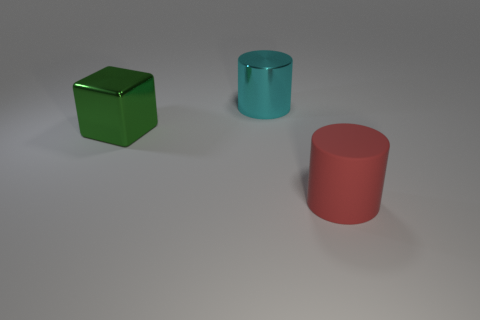What is the shape of the green object that is the same size as the red object?
Your answer should be compact. Cube. What shape is the matte object that is in front of the large cylinder behind the big cylinder that is in front of the cyan thing?
Offer a very short reply. Cylinder. Are there an equal number of cyan shiny cylinders in front of the green shiny cube and big blue rubber balls?
Your answer should be very brief. Yes. What number of matte objects are small cubes or green objects?
Your answer should be compact. 0. There is a red cylinder that is the same size as the green metal thing; what material is it?
Provide a short and direct response. Rubber. What number of other objects are the same material as the cyan cylinder?
Your answer should be compact. 1. Are there fewer cyan metal things in front of the red object than large brown blocks?
Your response must be concise. No. Is the rubber thing the same shape as the green thing?
Make the answer very short. No. There is another large thing that is the same shape as the cyan thing; what is its material?
Your answer should be very brief. Rubber. There is a thing to the left of the big thing behind the green thing; how big is it?
Offer a very short reply. Large. 